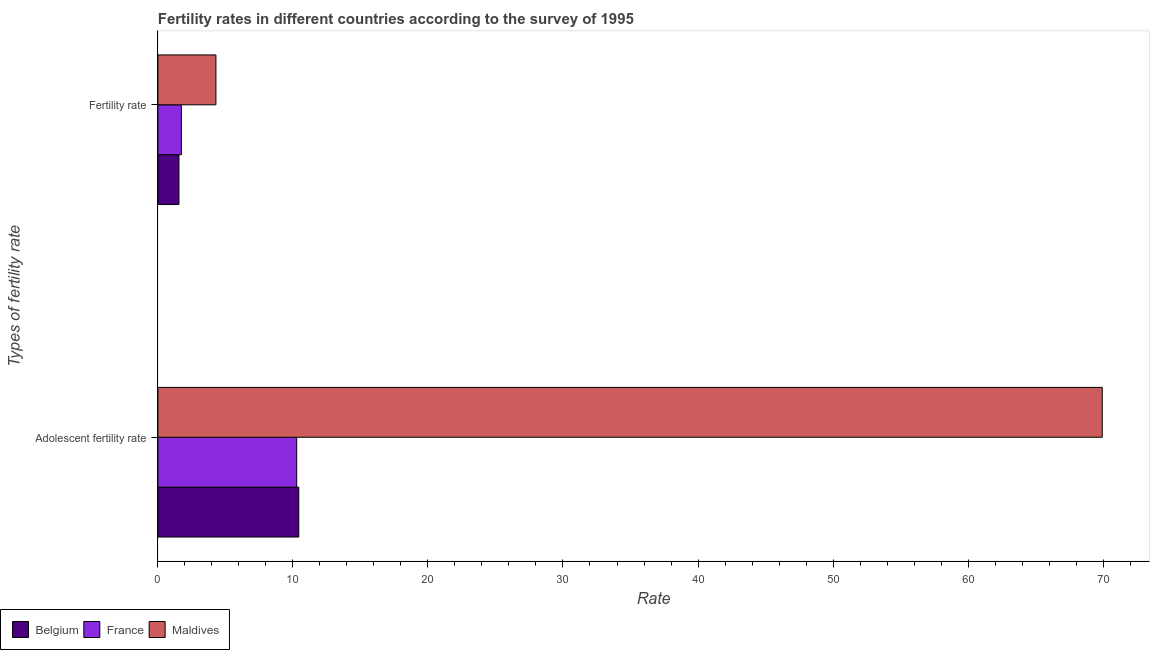How many bars are there on the 1st tick from the bottom?
Offer a very short reply. 3. What is the label of the 1st group of bars from the top?
Ensure brevity in your answer.  Fertility rate. What is the fertility rate in Belgium?
Your response must be concise. 1.56. Across all countries, what is the maximum adolescent fertility rate?
Your answer should be compact. 69.94. Across all countries, what is the minimum fertility rate?
Make the answer very short. 1.56. In which country was the adolescent fertility rate maximum?
Provide a succinct answer. Maldives. What is the total adolescent fertility rate in the graph?
Offer a very short reply. 90.65. What is the difference between the adolescent fertility rate in Maldives and that in France?
Provide a short and direct response. 59.66. What is the difference between the adolescent fertility rate in Belgium and the fertility rate in France?
Your response must be concise. 8.69. What is the average fertility rate per country?
Offer a very short reply. 2.53. What is the difference between the adolescent fertility rate and fertility rate in Maldives?
Give a very brief answer. 65.64. In how many countries, is the adolescent fertility rate greater than 30 ?
Give a very brief answer. 1. What is the ratio of the adolescent fertility rate in Belgium to that in Maldives?
Keep it short and to the point. 0.15. Is the adolescent fertility rate in Maldives less than that in France?
Offer a terse response. No. In how many countries, is the fertility rate greater than the average fertility rate taken over all countries?
Keep it short and to the point. 1. What does the 1st bar from the top in Fertility rate represents?
Your answer should be very brief. Maldives. What does the 3rd bar from the bottom in Fertility rate represents?
Offer a terse response. Maldives. Does the graph contain any zero values?
Keep it short and to the point. No. How many legend labels are there?
Make the answer very short. 3. What is the title of the graph?
Keep it short and to the point. Fertility rates in different countries according to the survey of 1995. What is the label or title of the X-axis?
Keep it short and to the point. Rate. What is the label or title of the Y-axis?
Offer a terse response. Types of fertility rate. What is the Rate of Belgium in Adolescent fertility rate?
Ensure brevity in your answer.  10.43. What is the Rate in France in Adolescent fertility rate?
Your answer should be compact. 10.28. What is the Rate of Maldives in Adolescent fertility rate?
Keep it short and to the point. 69.94. What is the Rate in Belgium in Fertility rate?
Offer a terse response. 1.56. What is the Rate in France in Fertility rate?
Your response must be concise. 1.74. What is the Rate of Maldives in Fertility rate?
Give a very brief answer. 4.3. Across all Types of fertility rate, what is the maximum Rate in Belgium?
Your answer should be compact. 10.43. Across all Types of fertility rate, what is the maximum Rate of France?
Provide a succinct answer. 10.28. Across all Types of fertility rate, what is the maximum Rate of Maldives?
Your answer should be compact. 69.94. Across all Types of fertility rate, what is the minimum Rate in Belgium?
Provide a succinct answer. 1.56. Across all Types of fertility rate, what is the minimum Rate of France?
Keep it short and to the point. 1.74. Across all Types of fertility rate, what is the minimum Rate of Maldives?
Ensure brevity in your answer.  4.3. What is the total Rate of Belgium in the graph?
Make the answer very short. 11.99. What is the total Rate of France in the graph?
Offer a terse response. 12.02. What is the total Rate of Maldives in the graph?
Provide a short and direct response. 74.24. What is the difference between the Rate in Belgium in Adolescent fertility rate and that in Fertility rate?
Your response must be concise. 8.87. What is the difference between the Rate of France in Adolescent fertility rate and that in Fertility rate?
Give a very brief answer. 8.54. What is the difference between the Rate of Maldives in Adolescent fertility rate and that in Fertility rate?
Your answer should be compact. 65.64. What is the difference between the Rate of Belgium in Adolescent fertility rate and the Rate of France in Fertility rate?
Make the answer very short. 8.69. What is the difference between the Rate of Belgium in Adolescent fertility rate and the Rate of Maldives in Fertility rate?
Offer a very short reply. 6.14. What is the difference between the Rate of France in Adolescent fertility rate and the Rate of Maldives in Fertility rate?
Make the answer very short. 5.98. What is the average Rate in Belgium per Types of fertility rate?
Your response must be concise. 6. What is the average Rate of France per Types of fertility rate?
Keep it short and to the point. 6.01. What is the average Rate in Maldives per Types of fertility rate?
Provide a short and direct response. 37.12. What is the difference between the Rate in Belgium and Rate in France in Adolescent fertility rate?
Your response must be concise. 0.15. What is the difference between the Rate of Belgium and Rate of Maldives in Adolescent fertility rate?
Offer a very short reply. -59.5. What is the difference between the Rate in France and Rate in Maldives in Adolescent fertility rate?
Ensure brevity in your answer.  -59.66. What is the difference between the Rate of Belgium and Rate of France in Fertility rate?
Ensure brevity in your answer.  -0.18. What is the difference between the Rate in Belgium and Rate in Maldives in Fertility rate?
Provide a succinct answer. -2.74. What is the difference between the Rate of France and Rate of Maldives in Fertility rate?
Your answer should be compact. -2.56. What is the ratio of the Rate in Belgium in Adolescent fertility rate to that in Fertility rate?
Offer a terse response. 6.69. What is the ratio of the Rate in France in Adolescent fertility rate to that in Fertility rate?
Your answer should be compact. 5.91. What is the ratio of the Rate in Maldives in Adolescent fertility rate to that in Fertility rate?
Make the answer very short. 16.27. What is the difference between the highest and the second highest Rate in Belgium?
Provide a short and direct response. 8.87. What is the difference between the highest and the second highest Rate in France?
Make the answer very short. 8.54. What is the difference between the highest and the second highest Rate in Maldives?
Provide a short and direct response. 65.64. What is the difference between the highest and the lowest Rate of Belgium?
Keep it short and to the point. 8.87. What is the difference between the highest and the lowest Rate of France?
Offer a very short reply. 8.54. What is the difference between the highest and the lowest Rate in Maldives?
Offer a terse response. 65.64. 